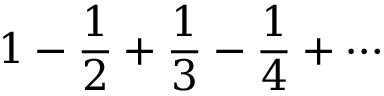Convert formula to latex. <formula><loc_0><loc_0><loc_500><loc_500>1 - { \frac { 1 } { 2 } } + { \frac { 1 } { 3 } } - { \frac { 1 } { 4 } } + \cdots</formula> 